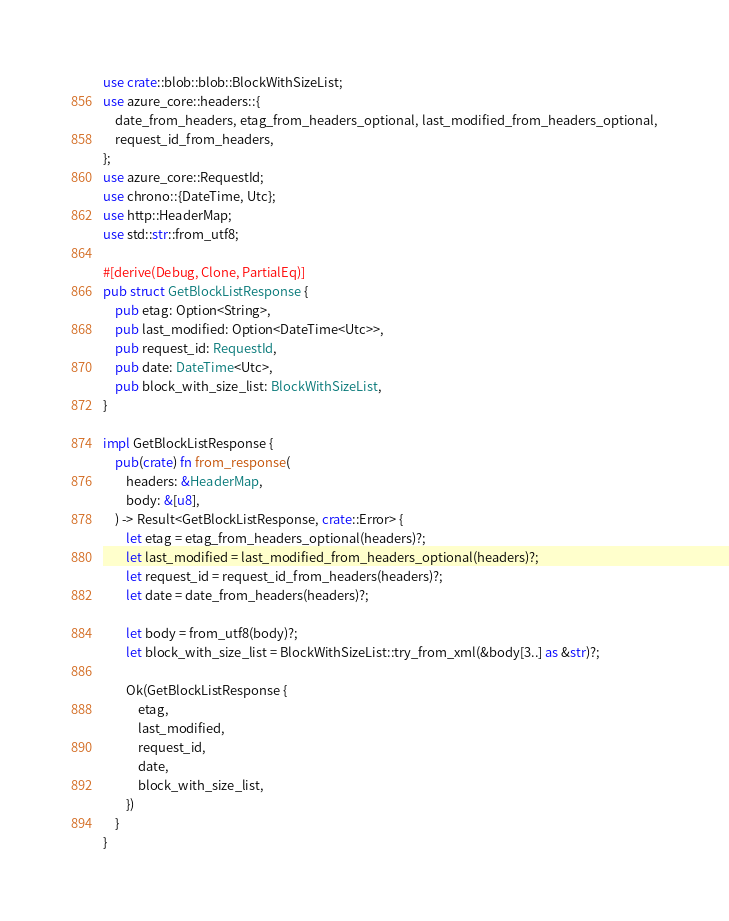<code> <loc_0><loc_0><loc_500><loc_500><_Rust_>use crate::blob::blob::BlockWithSizeList;
use azure_core::headers::{
    date_from_headers, etag_from_headers_optional, last_modified_from_headers_optional,
    request_id_from_headers,
};
use azure_core::RequestId;
use chrono::{DateTime, Utc};
use http::HeaderMap;
use std::str::from_utf8;

#[derive(Debug, Clone, PartialEq)]
pub struct GetBlockListResponse {
    pub etag: Option<String>,
    pub last_modified: Option<DateTime<Utc>>,
    pub request_id: RequestId,
    pub date: DateTime<Utc>,
    pub block_with_size_list: BlockWithSizeList,
}

impl GetBlockListResponse {
    pub(crate) fn from_response(
        headers: &HeaderMap,
        body: &[u8],
    ) -> Result<GetBlockListResponse, crate::Error> {
        let etag = etag_from_headers_optional(headers)?;
        let last_modified = last_modified_from_headers_optional(headers)?;
        let request_id = request_id_from_headers(headers)?;
        let date = date_from_headers(headers)?;

        let body = from_utf8(body)?;
        let block_with_size_list = BlockWithSizeList::try_from_xml(&body[3..] as &str)?;

        Ok(GetBlockListResponse {
            etag,
            last_modified,
            request_id,
            date,
            block_with_size_list,
        })
    }
}
</code> 